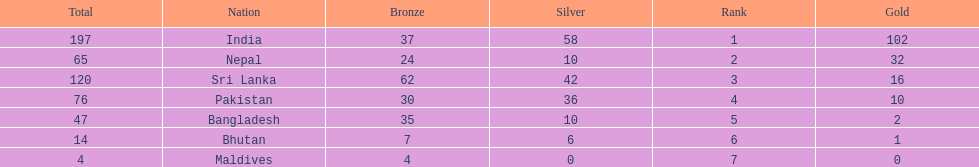How many gold medals did india win? 102. 